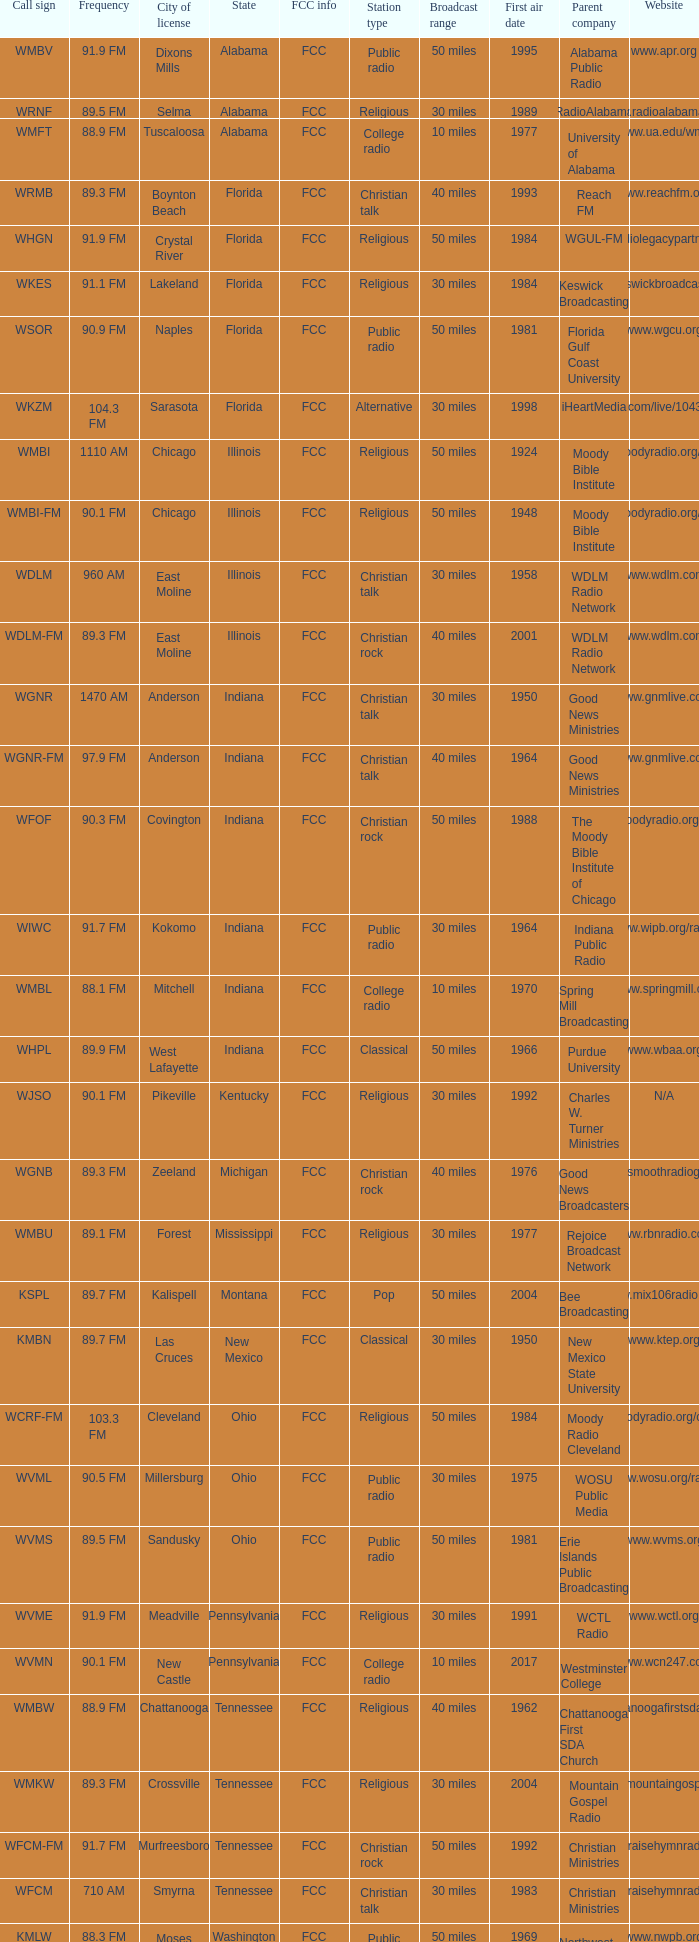What is the call sign for 90.9 FM which is in Florida? WSOR. Could you parse the entire table? {'header': ['Call sign', 'Frequency', 'City of license', 'State', 'FCC info', 'Station type', 'Broadcast range', 'First air date', 'Parent company', 'Website'], 'rows': [['WMBV', '91.9 FM', 'Dixons Mills', 'Alabama', 'FCC', 'Public radio', '50 miles', '1995', 'Alabama Public Radio', 'www.apr.org'], ['WRNF', '89.5 FM', 'Selma', 'Alabama', 'FCC', 'Religious', '30 miles', '1989', 'RadioAlabama', 'www.radioalabama.net'], ['WMFT', '88.9 FM', 'Tuscaloosa', 'Alabama', 'FCC', 'College radio', '10 miles', '1977', 'University of Alabama', 'www.ua.edu/wmft'], ['WRMB', '89.3 FM', 'Boynton Beach', 'Florida', 'FCC', 'Christian talk', '40 miles', '1993', 'Reach FM', 'www.reachfm.org'], ['WHGN', '91.9 FM', 'Crystal River', 'Florida', 'FCC', 'Religious', '50 miles', '1984', 'WGUL-FM', 'www.radiolegacypartners.com'], ['WKES', '91.1 FM', 'Lakeland', 'Florida', 'FCC', 'Religious', '30 miles', '1984', 'Keswick Broadcasting', 'www.keswickbroadcasting.org'], ['WSOR', '90.9 FM', 'Naples', 'Florida', 'FCC', 'Public radio', '50 miles', '1981', 'Florida Gulf Coast University', 'www.wgcu.org'], ['WKZM', '104.3 FM', 'Sarasota', 'Florida', 'FCC', 'Alternative', '30 miles', '1998', 'iHeartMedia', 'www.iheart.com/live/1043-kzm-4921/'], ['WMBI', '1110 AM', 'Chicago', 'Illinois', 'FCC', 'Religious', '50 miles', '1924', 'Moody Bible Institute', 'www.moodyradio.org/chicago'], ['WMBI-FM', '90.1 FM', 'Chicago', 'Illinois', 'FCC', 'Religious', '50 miles', '1948', 'Moody Bible Institute', 'www.moodyradio.org/chicago'], ['WDLM', '960 AM', 'East Moline', 'Illinois', 'FCC', 'Christian talk', '30 miles', '1958', 'WDLM Radio Network', 'www.wdlm.com'], ['WDLM-FM', '89.3 FM', 'East Moline', 'Illinois', 'FCC', 'Christian rock', '40 miles', '2001', 'WDLM Radio Network', 'www.wdlm.com'], ['WGNR', '1470 AM', 'Anderson', 'Indiana', 'FCC', 'Christian talk', '30 miles', '1950', 'Good News Ministries', 'www.gnmlive.com'], ['WGNR-FM', '97.9 FM', 'Anderson', 'Indiana', 'FCC', 'Christian talk', '40 miles', '1964', 'Good News Ministries', 'www.gnmlive.com'], ['WFOF', '90.3 FM', 'Covington', 'Indiana', 'FCC', 'Christian rock', '50 miles', '1988', 'The Moody Bible Institute of Chicago', 'www.moodyradio.org/indiana'], ['WIWC', '91.7 FM', 'Kokomo', 'Indiana', 'FCC', 'Public radio', '30 miles', '1964', 'Indiana Public Radio', 'www.wipb.org/radio'], ['WMBL', '88.1 FM', 'Mitchell', 'Indiana', 'FCC', 'College radio', '10 miles', '1970', 'Spring Mill Broadcasting', 'www.springmill.org'], ['WHPL', '89.9 FM', 'West Lafayette', 'Indiana', 'FCC', 'Classical', '50 miles', '1966', 'Purdue University', 'www.wbaa.org'], ['WJSO', '90.1 FM', 'Pikeville', 'Kentucky', 'FCC', 'Religious', '30 miles', '1992', 'Charles W. Turner Ministries', 'N/A'], ['WGNB', '89.3 FM', 'Zeeland', 'Michigan', 'FCC', 'Christian rock', '40 miles', '1976', 'Good News Broadcasters', 'www.smoothradiogr.com'], ['WMBU', '89.1 FM', 'Forest', 'Mississippi', 'FCC', 'Religious', '30 miles', '1977', 'Rejoice Broadcast Network', 'www.rbnradio.com'], ['KSPL', '89.7 FM', 'Kalispell', 'Montana', 'FCC', 'Pop', '50 miles', '2004', 'Bee Broadcasting', 'www.mix106radio.com'], ['KMBN', '89.7 FM', 'Las Cruces', 'New Mexico', 'FCC', 'Classical', '30 miles', '1950', 'New Mexico State University', 'www.ktep.org'], ['WCRF-FM', '103.3 FM', 'Cleveland', 'Ohio', 'FCC', 'Religious', '50 miles', '1984', 'Moody Radio Cleveland', 'www.moodyradio.org/cleveland'], ['WVML', '90.5 FM', 'Millersburg', 'Ohio', 'FCC', 'Public radio', '30 miles', '1975', 'WOSU Public Media', 'www.wosu.org/radio'], ['WVMS', '89.5 FM', 'Sandusky', 'Ohio', 'FCC', 'Public radio', '50 miles', '1981', 'Erie Islands Public Broadcasting', 'www.wvms.org'], ['WVME', '91.9 FM', 'Meadville', 'Pennsylvania', 'FCC', 'Religious', '30 miles', '1991', 'WCTL Radio', 'www.wctl.org'], ['WVMN', '90.1 FM', 'New Castle', 'Pennsylvania', 'FCC', 'College radio', '10 miles', '2017', 'Westminster College', 'www.wcn247.com'], ['WMBW', '88.9 FM', 'Chattanooga', 'Tennessee', 'FCC', 'Religious', '40 miles', '1962', 'Chattanooga First SDA Church', 'www.chattanoogafirstsda.com/radio'], ['WMKW', '89.3 FM', 'Crossville', 'Tennessee', 'FCC', 'Religious', '30 miles', '2004', 'Mountain Gospel Radio', 'www.mountaingospel.org'], ['WFCM-FM', '91.7 FM', 'Murfreesboro', 'Tennessee', 'FCC', 'Christian rock', '50 miles', '1992', 'Christian Ministries', 'www.praisehymnradio.com'], ['WFCM', '710 AM', 'Smyrna', 'Tennessee', 'FCC', 'Christian talk', '30 miles', '1983', 'Christian Ministries', 'www.praisehymnradio.com'], ['KMLW', '88.3 FM', 'Moses Lake', 'Washington', 'FCC', 'Public radio', '50 miles', '1969', 'Northwest Public Broadcasting', 'www.nwpb.org'], ['KMBI', '1330 AM', 'Spokane', 'Washington', 'FCC', 'Christian talk', '30 miles', '1957', 'Moody Broadcasting Network', 'www.moodyradiowest.com'], ['KMBI-FM', '107.9 FM', 'Spokane', 'Washington', 'FCC', 'Christian talk', '40 miles', '1962', 'Moody Broadcasting Network', 'www.moodyradiowest.com'], ['KMWY', '91.1 FM', 'Jackson', 'Wyoming', 'FCC', 'Classic rock', '50 miles', '2007', 'Lost Creek Broadcasting', 'www.1050classicrock.com']]} 